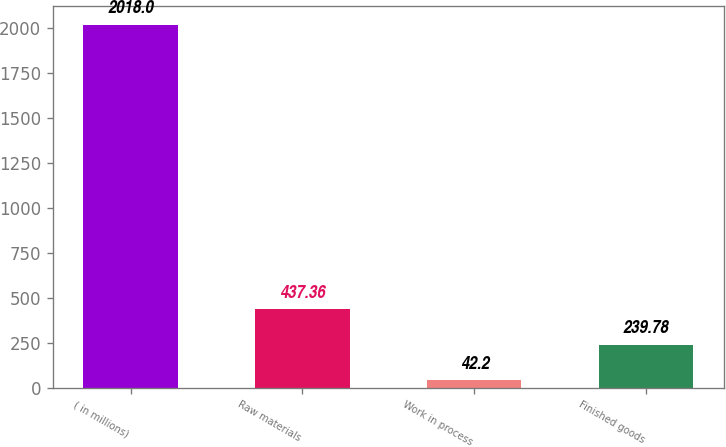<chart> <loc_0><loc_0><loc_500><loc_500><bar_chart><fcel>( in millions)<fcel>Raw materials<fcel>Work in process<fcel>Finished goods<nl><fcel>2018<fcel>437.36<fcel>42.2<fcel>239.78<nl></chart> 